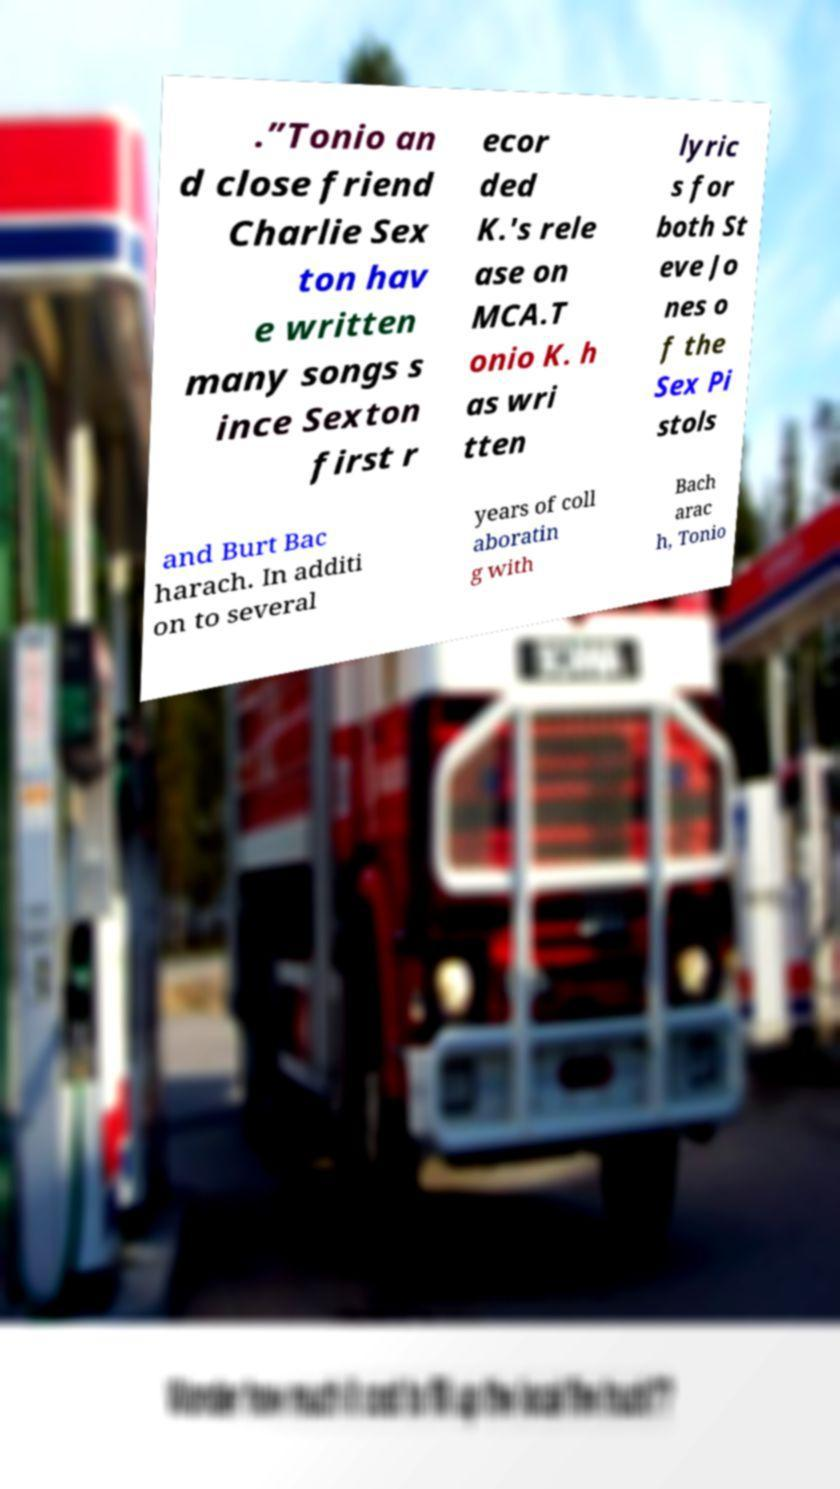For documentation purposes, I need the text within this image transcribed. Could you provide that? .”Tonio an d close friend Charlie Sex ton hav e written many songs s ince Sexton first r ecor ded K.'s rele ase on MCA.T onio K. h as wri tten lyric s for both St eve Jo nes o f the Sex Pi stols and Burt Bac harach. In additi on to several years of coll aboratin g with Bach arac h, Tonio 